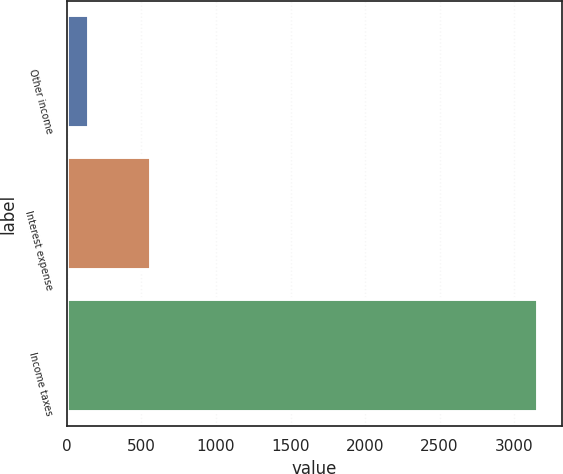<chart> <loc_0><loc_0><loc_500><loc_500><bar_chart><fcel>Other income<fcel>Interest expense<fcel>Income taxes<nl><fcel>151<fcel>561<fcel>3163<nl></chart> 